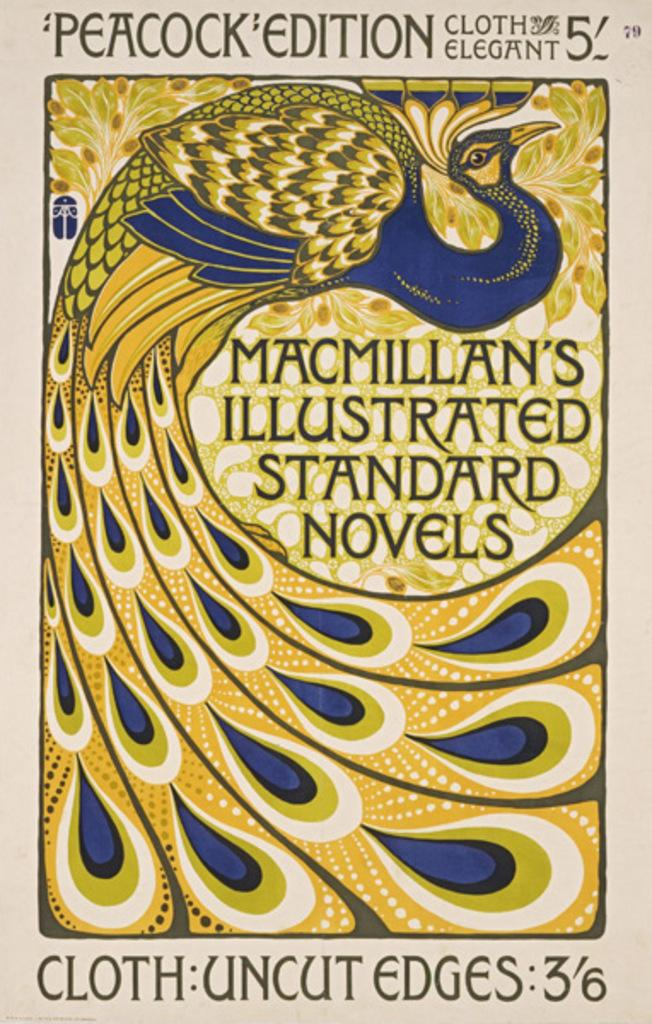<image>
Provide a brief description of the given image. A Peacock Edition novel about cloth titled Macmillan's Illustrated Standard Novels. 